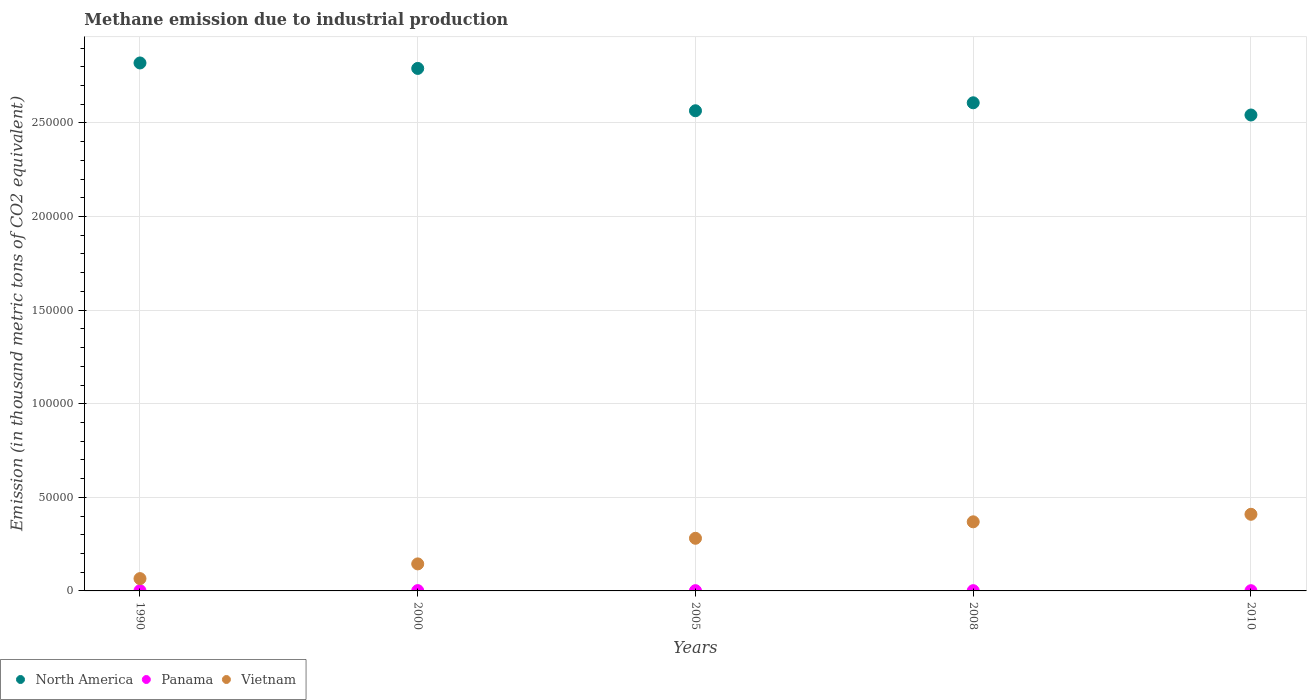What is the amount of methane emitted in North America in 2000?
Make the answer very short. 2.79e+05. Across all years, what is the maximum amount of methane emitted in Vietnam?
Make the answer very short. 4.09e+04. Across all years, what is the minimum amount of methane emitted in North America?
Offer a terse response. 2.54e+05. In which year was the amount of methane emitted in Vietnam minimum?
Make the answer very short. 1990. What is the total amount of methane emitted in Vietnam in the graph?
Offer a very short reply. 1.27e+05. What is the difference between the amount of methane emitted in Vietnam in 2008 and that in 2010?
Give a very brief answer. -4024.6. What is the difference between the amount of methane emitted in Vietnam in 2000 and the amount of methane emitted in North America in 2005?
Your answer should be compact. -2.42e+05. What is the average amount of methane emitted in Vietnam per year?
Your answer should be very brief. 2.54e+04. In the year 1990, what is the difference between the amount of methane emitted in Vietnam and amount of methane emitted in Panama?
Your answer should be very brief. 6445.6. In how many years, is the amount of methane emitted in Panama greater than 210000 thousand metric tons?
Your answer should be compact. 0. What is the ratio of the amount of methane emitted in North America in 1990 to that in 2000?
Keep it short and to the point. 1.01. Is the amount of methane emitted in North America in 2008 less than that in 2010?
Ensure brevity in your answer.  No. Is the difference between the amount of methane emitted in Vietnam in 2008 and 2010 greater than the difference between the amount of methane emitted in Panama in 2008 and 2010?
Your response must be concise. No. What is the difference between the highest and the second highest amount of methane emitted in North America?
Your answer should be very brief. 2915.4. What is the difference between the highest and the lowest amount of methane emitted in Panama?
Keep it short and to the point. 37.9. In how many years, is the amount of methane emitted in Vietnam greater than the average amount of methane emitted in Vietnam taken over all years?
Offer a terse response. 3. Is the sum of the amount of methane emitted in Panama in 1990 and 2005 greater than the maximum amount of methane emitted in Vietnam across all years?
Your answer should be compact. No. Is it the case that in every year, the sum of the amount of methane emitted in North America and amount of methane emitted in Panama  is greater than the amount of methane emitted in Vietnam?
Your answer should be compact. Yes. Is the amount of methane emitted in Vietnam strictly less than the amount of methane emitted in North America over the years?
Provide a succinct answer. Yes. How many dotlines are there?
Give a very brief answer. 3. What is the difference between two consecutive major ticks on the Y-axis?
Offer a terse response. 5.00e+04. Where does the legend appear in the graph?
Provide a succinct answer. Bottom left. How are the legend labels stacked?
Keep it short and to the point. Horizontal. What is the title of the graph?
Provide a short and direct response. Methane emission due to industrial production. What is the label or title of the X-axis?
Make the answer very short. Years. What is the label or title of the Y-axis?
Keep it short and to the point. Emission (in thousand metric tons of CO2 equivalent). What is the Emission (in thousand metric tons of CO2 equivalent) in North America in 1990?
Keep it short and to the point. 2.82e+05. What is the Emission (in thousand metric tons of CO2 equivalent) of Panama in 1990?
Your response must be concise. 128.9. What is the Emission (in thousand metric tons of CO2 equivalent) in Vietnam in 1990?
Offer a terse response. 6574.5. What is the Emission (in thousand metric tons of CO2 equivalent) of North America in 2000?
Provide a short and direct response. 2.79e+05. What is the Emission (in thousand metric tons of CO2 equivalent) of Panama in 2000?
Offer a terse response. 161.8. What is the Emission (in thousand metric tons of CO2 equivalent) in Vietnam in 2000?
Keep it short and to the point. 1.44e+04. What is the Emission (in thousand metric tons of CO2 equivalent) in North America in 2005?
Give a very brief answer. 2.57e+05. What is the Emission (in thousand metric tons of CO2 equivalent) of Panama in 2005?
Your answer should be very brief. 135.8. What is the Emission (in thousand metric tons of CO2 equivalent) of Vietnam in 2005?
Keep it short and to the point. 2.81e+04. What is the Emission (in thousand metric tons of CO2 equivalent) of North America in 2008?
Offer a terse response. 2.61e+05. What is the Emission (in thousand metric tons of CO2 equivalent) of Panama in 2008?
Provide a succinct answer. 135.3. What is the Emission (in thousand metric tons of CO2 equivalent) of Vietnam in 2008?
Your answer should be very brief. 3.69e+04. What is the Emission (in thousand metric tons of CO2 equivalent) in North America in 2010?
Make the answer very short. 2.54e+05. What is the Emission (in thousand metric tons of CO2 equivalent) in Panama in 2010?
Provide a short and direct response. 123.9. What is the Emission (in thousand metric tons of CO2 equivalent) of Vietnam in 2010?
Your answer should be compact. 4.09e+04. Across all years, what is the maximum Emission (in thousand metric tons of CO2 equivalent) of North America?
Give a very brief answer. 2.82e+05. Across all years, what is the maximum Emission (in thousand metric tons of CO2 equivalent) of Panama?
Keep it short and to the point. 161.8. Across all years, what is the maximum Emission (in thousand metric tons of CO2 equivalent) in Vietnam?
Keep it short and to the point. 4.09e+04. Across all years, what is the minimum Emission (in thousand metric tons of CO2 equivalent) in North America?
Provide a succinct answer. 2.54e+05. Across all years, what is the minimum Emission (in thousand metric tons of CO2 equivalent) of Panama?
Your answer should be very brief. 123.9. Across all years, what is the minimum Emission (in thousand metric tons of CO2 equivalent) of Vietnam?
Give a very brief answer. 6574.5. What is the total Emission (in thousand metric tons of CO2 equivalent) in North America in the graph?
Offer a terse response. 1.33e+06. What is the total Emission (in thousand metric tons of CO2 equivalent) in Panama in the graph?
Your response must be concise. 685.7. What is the total Emission (in thousand metric tons of CO2 equivalent) in Vietnam in the graph?
Offer a very short reply. 1.27e+05. What is the difference between the Emission (in thousand metric tons of CO2 equivalent) in North America in 1990 and that in 2000?
Keep it short and to the point. 2915.4. What is the difference between the Emission (in thousand metric tons of CO2 equivalent) of Panama in 1990 and that in 2000?
Offer a very short reply. -32.9. What is the difference between the Emission (in thousand metric tons of CO2 equivalent) of Vietnam in 1990 and that in 2000?
Give a very brief answer. -7863.6. What is the difference between the Emission (in thousand metric tons of CO2 equivalent) of North America in 1990 and that in 2005?
Provide a short and direct response. 2.55e+04. What is the difference between the Emission (in thousand metric tons of CO2 equivalent) in Panama in 1990 and that in 2005?
Offer a very short reply. -6.9. What is the difference between the Emission (in thousand metric tons of CO2 equivalent) of Vietnam in 1990 and that in 2005?
Your answer should be compact. -2.15e+04. What is the difference between the Emission (in thousand metric tons of CO2 equivalent) in North America in 1990 and that in 2008?
Your answer should be compact. 2.13e+04. What is the difference between the Emission (in thousand metric tons of CO2 equivalent) in Vietnam in 1990 and that in 2008?
Your answer should be compact. -3.03e+04. What is the difference between the Emission (in thousand metric tons of CO2 equivalent) in North America in 1990 and that in 2010?
Provide a short and direct response. 2.78e+04. What is the difference between the Emission (in thousand metric tons of CO2 equivalent) of Vietnam in 1990 and that in 2010?
Keep it short and to the point. -3.44e+04. What is the difference between the Emission (in thousand metric tons of CO2 equivalent) of North America in 2000 and that in 2005?
Your answer should be compact. 2.26e+04. What is the difference between the Emission (in thousand metric tons of CO2 equivalent) in Vietnam in 2000 and that in 2005?
Your response must be concise. -1.37e+04. What is the difference between the Emission (in thousand metric tons of CO2 equivalent) in North America in 2000 and that in 2008?
Your answer should be compact. 1.84e+04. What is the difference between the Emission (in thousand metric tons of CO2 equivalent) in Vietnam in 2000 and that in 2008?
Your answer should be compact. -2.25e+04. What is the difference between the Emission (in thousand metric tons of CO2 equivalent) of North America in 2000 and that in 2010?
Offer a terse response. 2.49e+04. What is the difference between the Emission (in thousand metric tons of CO2 equivalent) in Panama in 2000 and that in 2010?
Offer a terse response. 37.9. What is the difference between the Emission (in thousand metric tons of CO2 equivalent) of Vietnam in 2000 and that in 2010?
Provide a short and direct response. -2.65e+04. What is the difference between the Emission (in thousand metric tons of CO2 equivalent) in North America in 2005 and that in 2008?
Provide a short and direct response. -4257. What is the difference between the Emission (in thousand metric tons of CO2 equivalent) of Vietnam in 2005 and that in 2008?
Your answer should be very brief. -8796. What is the difference between the Emission (in thousand metric tons of CO2 equivalent) in North America in 2005 and that in 2010?
Offer a terse response. 2264.9. What is the difference between the Emission (in thousand metric tons of CO2 equivalent) of Vietnam in 2005 and that in 2010?
Keep it short and to the point. -1.28e+04. What is the difference between the Emission (in thousand metric tons of CO2 equivalent) in North America in 2008 and that in 2010?
Offer a terse response. 6521.9. What is the difference between the Emission (in thousand metric tons of CO2 equivalent) in Vietnam in 2008 and that in 2010?
Your answer should be very brief. -4024.6. What is the difference between the Emission (in thousand metric tons of CO2 equivalent) of North America in 1990 and the Emission (in thousand metric tons of CO2 equivalent) of Panama in 2000?
Your answer should be very brief. 2.82e+05. What is the difference between the Emission (in thousand metric tons of CO2 equivalent) in North America in 1990 and the Emission (in thousand metric tons of CO2 equivalent) in Vietnam in 2000?
Your answer should be compact. 2.68e+05. What is the difference between the Emission (in thousand metric tons of CO2 equivalent) of Panama in 1990 and the Emission (in thousand metric tons of CO2 equivalent) of Vietnam in 2000?
Your answer should be very brief. -1.43e+04. What is the difference between the Emission (in thousand metric tons of CO2 equivalent) of North America in 1990 and the Emission (in thousand metric tons of CO2 equivalent) of Panama in 2005?
Keep it short and to the point. 2.82e+05. What is the difference between the Emission (in thousand metric tons of CO2 equivalent) of North America in 1990 and the Emission (in thousand metric tons of CO2 equivalent) of Vietnam in 2005?
Ensure brevity in your answer.  2.54e+05. What is the difference between the Emission (in thousand metric tons of CO2 equivalent) in Panama in 1990 and the Emission (in thousand metric tons of CO2 equivalent) in Vietnam in 2005?
Make the answer very short. -2.80e+04. What is the difference between the Emission (in thousand metric tons of CO2 equivalent) in North America in 1990 and the Emission (in thousand metric tons of CO2 equivalent) in Panama in 2008?
Your answer should be compact. 2.82e+05. What is the difference between the Emission (in thousand metric tons of CO2 equivalent) in North America in 1990 and the Emission (in thousand metric tons of CO2 equivalent) in Vietnam in 2008?
Your answer should be very brief. 2.45e+05. What is the difference between the Emission (in thousand metric tons of CO2 equivalent) in Panama in 1990 and the Emission (in thousand metric tons of CO2 equivalent) in Vietnam in 2008?
Your answer should be very brief. -3.68e+04. What is the difference between the Emission (in thousand metric tons of CO2 equivalent) of North America in 1990 and the Emission (in thousand metric tons of CO2 equivalent) of Panama in 2010?
Your answer should be very brief. 2.82e+05. What is the difference between the Emission (in thousand metric tons of CO2 equivalent) in North America in 1990 and the Emission (in thousand metric tons of CO2 equivalent) in Vietnam in 2010?
Keep it short and to the point. 2.41e+05. What is the difference between the Emission (in thousand metric tons of CO2 equivalent) of Panama in 1990 and the Emission (in thousand metric tons of CO2 equivalent) of Vietnam in 2010?
Keep it short and to the point. -4.08e+04. What is the difference between the Emission (in thousand metric tons of CO2 equivalent) of North America in 2000 and the Emission (in thousand metric tons of CO2 equivalent) of Panama in 2005?
Your response must be concise. 2.79e+05. What is the difference between the Emission (in thousand metric tons of CO2 equivalent) in North America in 2000 and the Emission (in thousand metric tons of CO2 equivalent) in Vietnam in 2005?
Provide a succinct answer. 2.51e+05. What is the difference between the Emission (in thousand metric tons of CO2 equivalent) in Panama in 2000 and the Emission (in thousand metric tons of CO2 equivalent) in Vietnam in 2005?
Provide a succinct answer. -2.80e+04. What is the difference between the Emission (in thousand metric tons of CO2 equivalent) of North America in 2000 and the Emission (in thousand metric tons of CO2 equivalent) of Panama in 2008?
Make the answer very short. 2.79e+05. What is the difference between the Emission (in thousand metric tons of CO2 equivalent) in North America in 2000 and the Emission (in thousand metric tons of CO2 equivalent) in Vietnam in 2008?
Provide a succinct answer. 2.42e+05. What is the difference between the Emission (in thousand metric tons of CO2 equivalent) of Panama in 2000 and the Emission (in thousand metric tons of CO2 equivalent) of Vietnam in 2008?
Your answer should be very brief. -3.68e+04. What is the difference between the Emission (in thousand metric tons of CO2 equivalent) of North America in 2000 and the Emission (in thousand metric tons of CO2 equivalent) of Panama in 2010?
Your answer should be very brief. 2.79e+05. What is the difference between the Emission (in thousand metric tons of CO2 equivalent) in North America in 2000 and the Emission (in thousand metric tons of CO2 equivalent) in Vietnam in 2010?
Your answer should be very brief. 2.38e+05. What is the difference between the Emission (in thousand metric tons of CO2 equivalent) of Panama in 2000 and the Emission (in thousand metric tons of CO2 equivalent) of Vietnam in 2010?
Your response must be concise. -4.08e+04. What is the difference between the Emission (in thousand metric tons of CO2 equivalent) in North America in 2005 and the Emission (in thousand metric tons of CO2 equivalent) in Panama in 2008?
Your answer should be very brief. 2.56e+05. What is the difference between the Emission (in thousand metric tons of CO2 equivalent) of North America in 2005 and the Emission (in thousand metric tons of CO2 equivalent) of Vietnam in 2008?
Offer a terse response. 2.20e+05. What is the difference between the Emission (in thousand metric tons of CO2 equivalent) in Panama in 2005 and the Emission (in thousand metric tons of CO2 equivalent) in Vietnam in 2008?
Provide a short and direct response. -3.68e+04. What is the difference between the Emission (in thousand metric tons of CO2 equivalent) of North America in 2005 and the Emission (in thousand metric tons of CO2 equivalent) of Panama in 2010?
Offer a very short reply. 2.56e+05. What is the difference between the Emission (in thousand metric tons of CO2 equivalent) of North America in 2005 and the Emission (in thousand metric tons of CO2 equivalent) of Vietnam in 2010?
Make the answer very short. 2.16e+05. What is the difference between the Emission (in thousand metric tons of CO2 equivalent) of Panama in 2005 and the Emission (in thousand metric tons of CO2 equivalent) of Vietnam in 2010?
Provide a succinct answer. -4.08e+04. What is the difference between the Emission (in thousand metric tons of CO2 equivalent) of North America in 2008 and the Emission (in thousand metric tons of CO2 equivalent) of Panama in 2010?
Your answer should be compact. 2.61e+05. What is the difference between the Emission (in thousand metric tons of CO2 equivalent) in North America in 2008 and the Emission (in thousand metric tons of CO2 equivalent) in Vietnam in 2010?
Your response must be concise. 2.20e+05. What is the difference between the Emission (in thousand metric tons of CO2 equivalent) in Panama in 2008 and the Emission (in thousand metric tons of CO2 equivalent) in Vietnam in 2010?
Give a very brief answer. -4.08e+04. What is the average Emission (in thousand metric tons of CO2 equivalent) in North America per year?
Your answer should be compact. 2.67e+05. What is the average Emission (in thousand metric tons of CO2 equivalent) in Panama per year?
Your response must be concise. 137.14. What is the average Emission (in thousand metric tons of CO2 equivalent) of Vietnam per year?
Offer a very short reply. 2.54e+04. In the year 1990, what is the difference between the Emission (in thousand metric tons of CO2 equivalent) in North America and Emission (in thousand metric tons of CO2 equivalent) in Panama?
Offer a terse response. 2.82e+05. In the year 1990, what is the difference between the Emission (in thousand metric tons of CO2 equivalent) in North America and Emission (in thousand metric tons of CO2 equivalent) in Vietnam?
Ensure brevity in your answer.  2.75e+05. In the year 1990, what is the difference between the Emission (in thousand metric tons of CO2 equivalent) in Panama and Emission (in thousand metric tons of CO2 equivalent) in Vietnam?
Give a very brief answer. -6445.6. In the year 2000, what is the difference between the Emission (in thousand metric tons of CO2 equivalent) in North America and Emission (in thousand metric tons of CO2 equivalent) in Panama?
Offer a terse response. 2.79e+05. In the year 2000, what is the difference between the Emission (in thousand metric tons of CO2 equivalent) of North America and Emission (in thousand metric tons of CO2 equivalent) of Vietnam?
Make the answer very short. 2.65e+05. In the year 2000, what is the difference between the Emission (in thousand metric tons of CO2 equivalent) in Panama and Emission (in thousand metric tons of CO2 equivalent) in Vietnam?
Offer a very short reply. -1.43e+04. In the year 2005, what is the difference between the Emission (in thousand metric tons of CO2 equivalent) in North America and Emission (in thousand metric tons of CO2 equivalent) in Panama?
Keep it short and to the point. 2.56e+05. In the year 2005, what is the difference between the Emission (in thousand metric tons of CO2 equivalent) in North America and Emission (in thousand metric tons of CO2 equivalent) in Vietnam?
Ensure brevity in your answer.  2.28e+05. In the year 2005, what is the difference between the Emission (in thousand metric tons of CO2 equivalent) in Panama and Emission (in thousand metric tons of CO2 equivalent) in Vietnam?
Offer a very short reply. -2.80e+04. In the year 2008, what is the difference between the Emission (in thousand metric tons of CO2 equivalent) in North America and Emission (in thousand metric tons of CO2 equivalent) in Panama?
Offer a very short reply. 2.61e+05. In the year 2008, what is the difference between the Emission (in thousand metric tons of CO2 equivalent) of North America and Emission (in thousand metric tons of CO2 equivalent) of Vietnam?
Provide a succinct answer. 2.24e+05. In the year 2008, what is the difference between the Emission (in thousand metric tons of CO2 equivalent) in Panama and Emission (in thousand metric tons of CO2 equivalent) in Vietnam?
Your response must be concise. -3.68e+04. In the year 2010, what is the difference between the Emission (in thousand metric tons of CO2 equivalent) of North America and Emission (in thousand metric tons of CO2 equivalent) of Panama?
Keep it short and to the point. 2.54e+05. In the year 2010, what is the difference between the Emission (in thousand metric tons of CO2 equivalent) in North America and Emission (in thousand metric tons of CO2 equivalent) in Vietnam?
Your response must be concise. 2.13e+05. In the year 2010, what is the difference between the Emission (in thousand metric tons of CO2 equivalent) in Panama and Emission (in thousand metric tons of CO2 equivalent) in Vietnam?
Your answer should be compact. -4.08e+04. What is the ratio of the Emission (in thousand metric tons of CO2 equivalent) of North America in 1990 to that in 2000?
Provide a succinct answer. 1.01. What is the ratio of the Emission (in thousand metric tons of CO2 equivalent) of Panama in 1990 to that in 2000?
Ensure brevity in your answer.  0.8. What is the ratio of the Emission (in thousand metric tons of CO2 equivalent) in Vietnam in 1990 to that in 2000?
Your answer should be very brief. 0.46. What is the ratio of the Emission (in thousand metric tons of CO2 equivalent) of North America in 1990 to that in 2005?
Keep it short and to the point. 1.1. What is the ratio of the Emission (in thousand metric tons of CO2 equivalent) in Panama in 1990 to that in 2005?
Make the answer very short. 0.95. What is the ratio of the Emission (in thousand metric tons of CO2 equivalent) in Vietnam in 1990 to that in 2005?
Provide a short and direct response. 0.23. What is the ratio of the Emission (in thousand metric tons of CO2 equivalent) in North America in 1990 to that in 2008?
Offer a terse response. 1.08. What is the ratio of the Emission (in thousand metric tons of CO2 equivalent) of Panama in 1990 to that in 2008?
Offer a terse response. 0.95. What is the ratio of the Emission (in thousand metric tons of CO2 equivalent) of Vietnam in 1990 to that in 2008?
Give a very brief answer. 0.18. What is the ratio of the Emission (in thousand metric tons of CO2 equivalent) of North America in 1990 to that in 2010?
Keep it short and to the point. 1.11. What is the ratio of the Emission (in thousand metric tons of CO2 equivalent) of Panama in 1990 to that in 2010?
Provide a short and direct response. 1.04. What is the ratio of the Emission (in thousand metric tons of CO2 equivalent) of Vietnam in 1990 to that in 2010?
Your answer should be very brief. 0.16. What is the ratio of the Emission (in thousand metric tons of CO2 equivalent) of North America in 2000 to that in 2005?
Provide a succinct answer. 1.09. What is the ratio of the Emission (in thousand metric tons of CO2 equivalent) in Panama in 2000 to that in 2005?
Provide a short and direct response. 1.19. What is the ratio of the Emission (in thousand metric tons of CO2 equivalent) in Vietnam in 2000 to that in 2005?
Offer a terse response. 0.51. What is the ratio of the Emission (in thousand metric tons of CO2 equivalent) in North America in 2000 to that in 2008?
Give a very brief answer. 1.07. What is the ratio of the Emission (in thousand metric tons of CO2 equivalent) in Panama in 2000 to that in 2008?
Provide a short and direct response. 1.2. What is the ratio of the Emission (in thousand metric tons of CO2 equivalent) in Vietnam in 2000 to that in 2008?
Offer a very short reply. 0.39. What is the ratio of the Emission (in thousand metric tons of CO2 equivalent) in North America in 2000 to that in 2010?
Your response must be concise. 1.1. What is the ratio of the Emission (in thousand metric tons of CO2 equivalent) of Panama in 2000 to that in 2010?
Ensure brevity in your answer.  1.31. What is the ratio of the Emission (in thousand metric tons of CO2 equivalent) in Vietnam in 2000 to that in 2010?
Provide a short and direct response. 0.35. What is the ratio of the Emission (in thousand metric tons of CO2 equivalent) in North America in 2005 to that in 2008?
Your answer should be very brief. 0.98. What is the ratio of the Emission (in thousand metric tons of CO2 equivalent) of Panama in 2005 to that in 2008?
Offer a terse response. 1. What is the ratio of the Emission (in thousand metric tons of CO2 equivalent) of Vietnam in 2005 to that in 2008?
Make the answer very short. 0.76. What is the ratio of the Emission (in thousand metric tons of CO2 equivalent) of North America in 2005 to that in 2010?
Provide a succinct answer. 1.01. What is the ratio of the Emission (in thousand metric tons of CO2 equivalent) of Panama in 2005 to that in 2010?
Give a very brief answer. 1.1. What is the ratio of the Emission (in thousand metric tons of CO2 equivalent) of Vietnam in 2005 to that in 2010?
Provide a short and direct response. 0.69. What is the ratio of the Emission (in thousand metric tons of CO2 equivalent) of North America in 2008 to that in 2010?
Offer a very short reply. 1.03. What is the ratio of the Emission (in thousand metric tons of CO2 equivalent) of Panama in 2008 to that in 2010?
Your response must be concise. 1.09. What is the ratio of the Emission (in thousand metric tons of CO2 equivalent) in Vietnam in 2008 to that in 2010?
Offer a very short reply. 0.9. What is the difference between the highest and the second highest Emission (in thousand metric tons of CO2 equivalent) of North America?
Your answer should be compact. 2915.4. What is the difference between the highest and the second highest Emission (in thousand metric tons of CO2 equivalent) of Vietnam?
Provide a short and direct response. 4024.6. What is the difference between the highest and the lowest Emission (in thousand metric tons of CO2 equivalent) in North America?
Your answer should be compact. 2.78e+04. What is the difference between the highest and the lowest Emission (in thousand metric tons of CO2 equivalent) in Panama?
Make the answer very short. 37.9. What is the difference between the highest and the lowest Emission (in thousand metric tons of CO2 equivalent) of Vietnam?
Provide a succinct answer. 3.44e+04. 